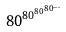Convert formula to latex. <formula><loc_0><loc_0><loc_500><loc_500>8 0 ^ { 8 0 ^ { 8 0 ^ { 8 0 ^ { \dots } } } }</formula> 